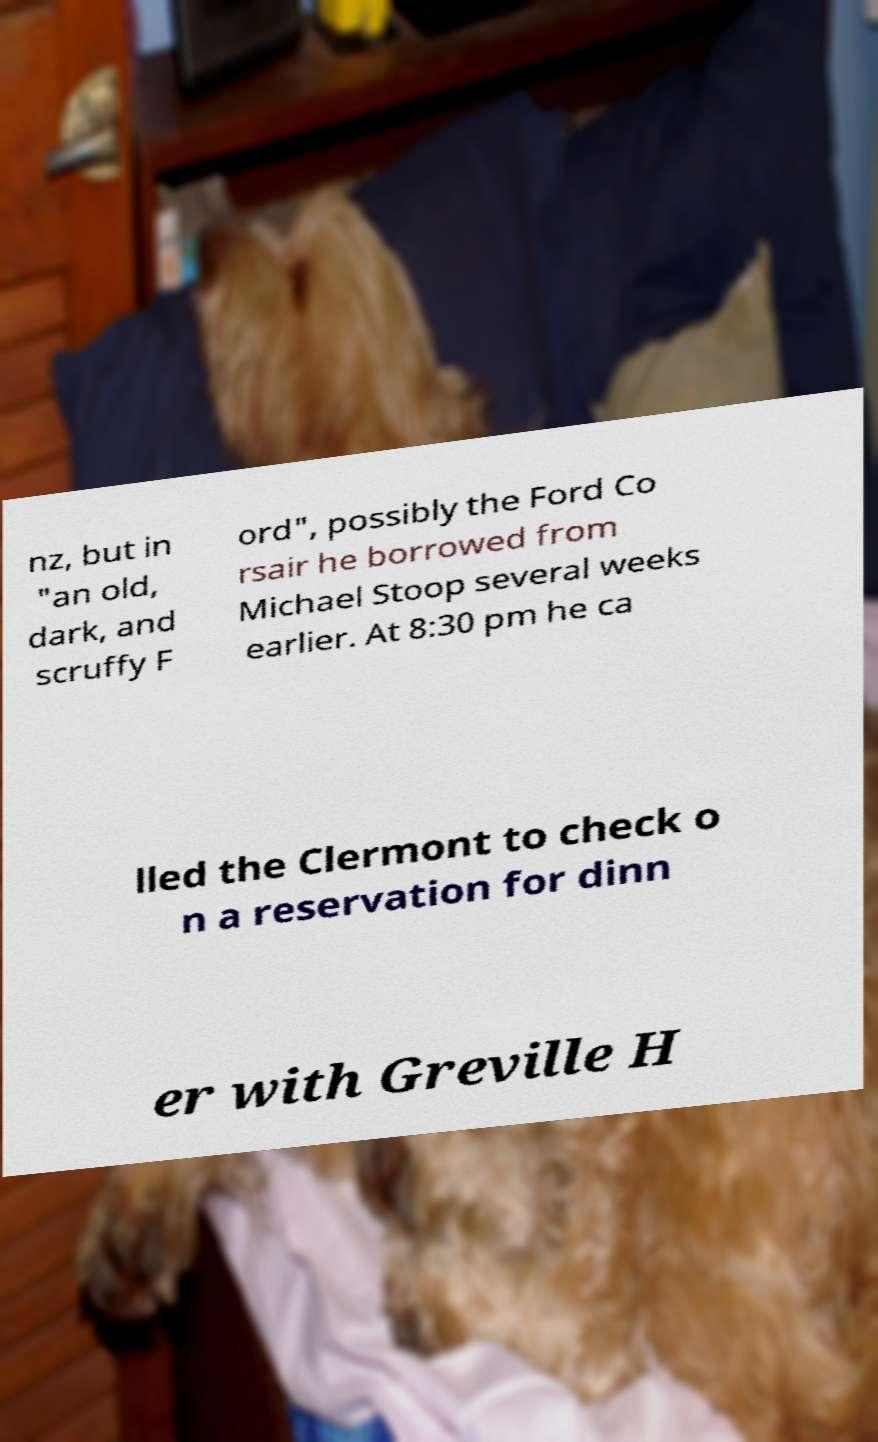What messages or text are displayed in this image? I need them in a readable, typed format. nz, but in "an old, dark, and scruffy F ord", possibly the Ford Co rsair he borrowed from Michael Stoop several weeks earlier. At 8:30 pm he ca lled the Clermont to check o n a reservation for dinn er with Greville H 